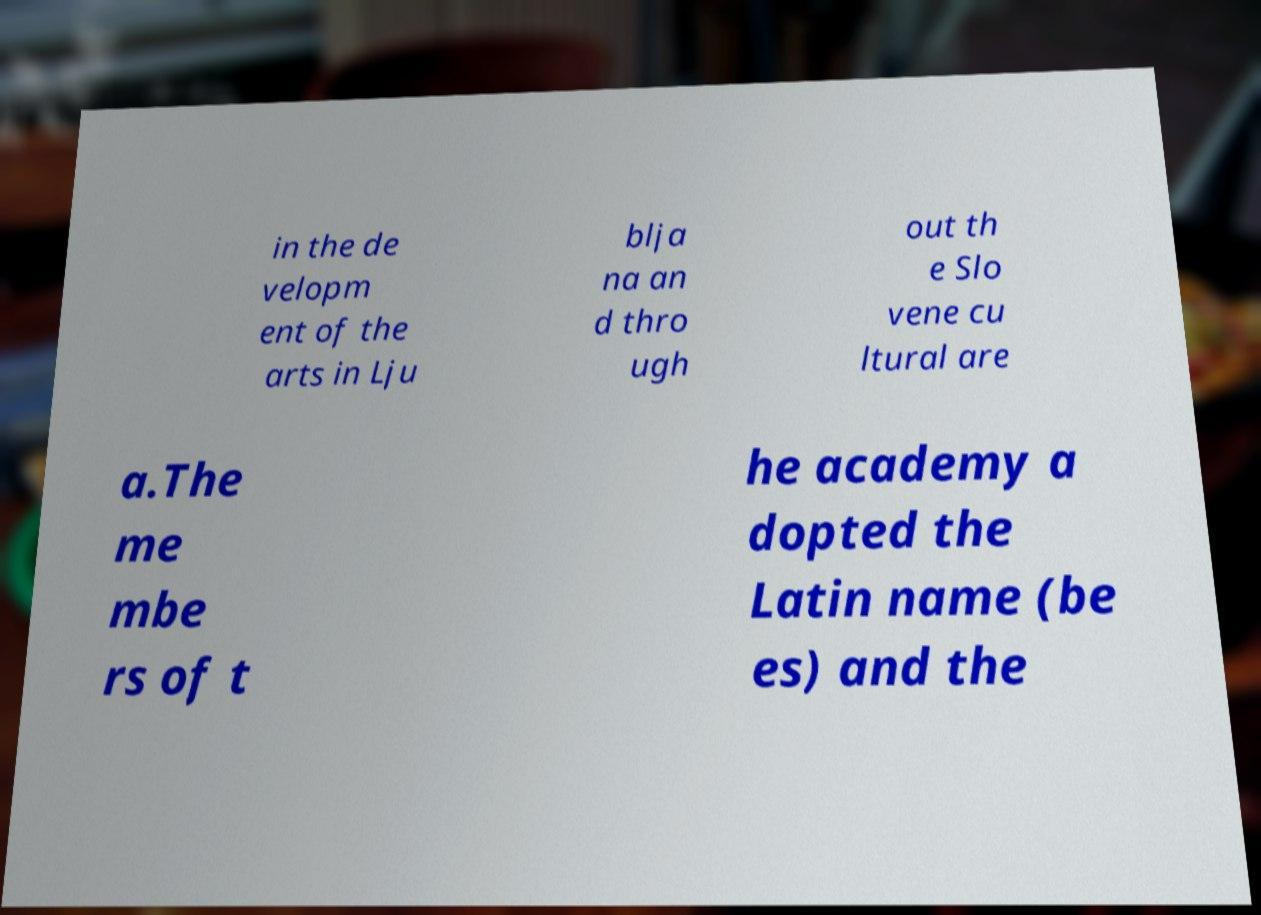What messages or text are displayed in this image? I need them in a readable, typed format. in the de velopm ent of the arts in Lju blja na an d thro ugh out th e Slo vene cu ltural are a.The me mbe rs of t he academy a dopted the Latin name (be es) and the 